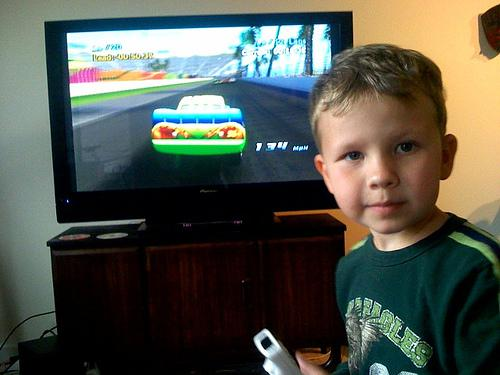Question: who is in picture?
Choices:
A. A girl.
B. A woman.
C. A boy.
D. A man.
Answer with the letter. Answer: C Question: what does boys shirt say?
Choices:
A. Hawks.
B. Falcons.
C. Beagles.
D. Eagles.
Answer with the letter. Answer: D Question: how many discs are os stand below t.v.?
Choices:
A. Three.
B. Four.
C. Two.
D. Five.
Answer with the letter. Answer: C Question: where numbers are on t.v.?
Choices:
A. 134.
B. 143.
C. 431.
D. 133.
Answer with the letter. Answer: A Question: where are the stripes on the shirt?
Choices:
A. Shoulder.
B. Chest.
C. Sleeve.
D. Back.
Answer with the letter. Answer: A Question: where is boys nose?
Choices:
A. Top of face.
B. Bottom of face.
C. Left of face.
D. Middle of face.
Answer with the letter. Answer: D 